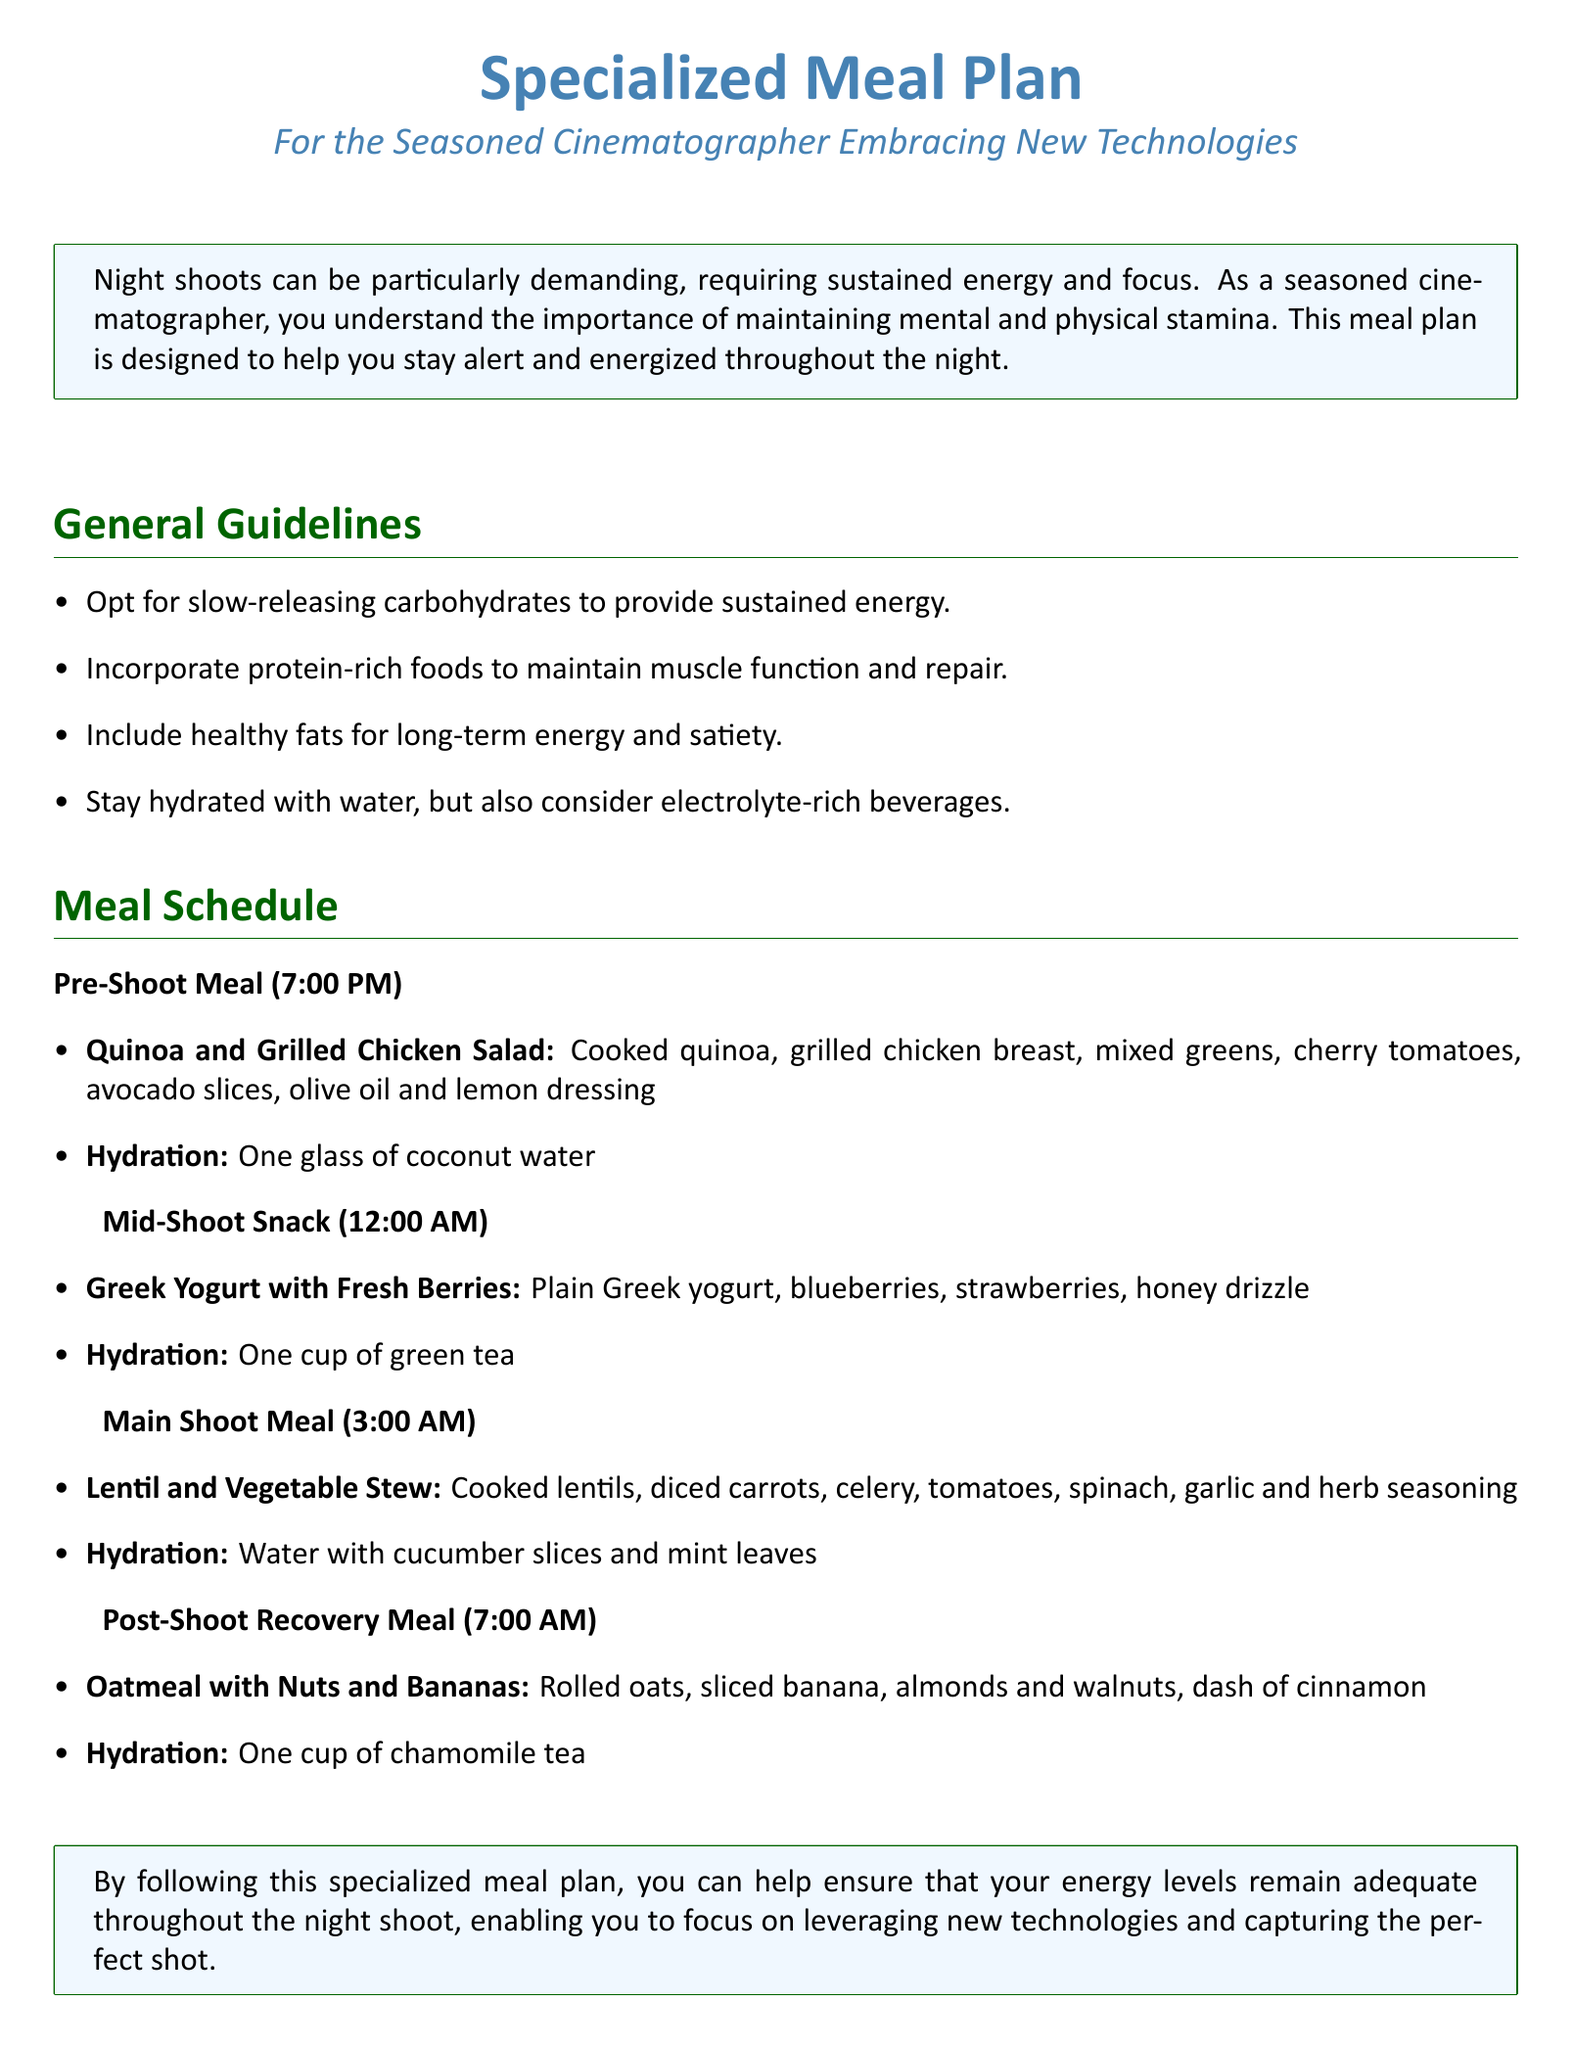What is the pre-shoot meal? The pre-shoot meal is specifically mentioned in the document, highlighting the items to be consumed at 7:00 PM.
Answer: Quinoa and Grilled Chicken Salad What time is the mid-shoot snack scheduled? The schedule outlines specific meal times, and the mid-shoot snack is listed at 12:00 AM.
Answer: 12:00 AM What type of hydration is included with the main shoot meal? The hydration associated with the main shoot meal is detailed in the document, specifying beverages to be consumed.
Answer: Water with cucumber slices and mint leaves How many meals are included in the meal plan? By counting the meals listed in the schedule section, the total number can be determined.
Answer: Four meals What is the primary component of the post-shoot recovery meal? The post-shoot recovery meal consists of specific ingredients, which are detailed in the document.
Answer: Oatmeal with Nuts and Bananas Why is hydration important during night shoots? The document emphasizes hydration as a key aspect of the meal plan, indicating its role in maintaining energy levels.
Answer: To stay hydrated Which beverage is suggested for the mid-shoot snack? The document specifies the beverage to be consumed with the mid-shoot snack.
Answer: One cup of green tea What type of fats is recommended in the meal plan? The general guidelines suggest incorporating certain types of fats for energy, which are noted in the document.
Answer: Healthy fats 